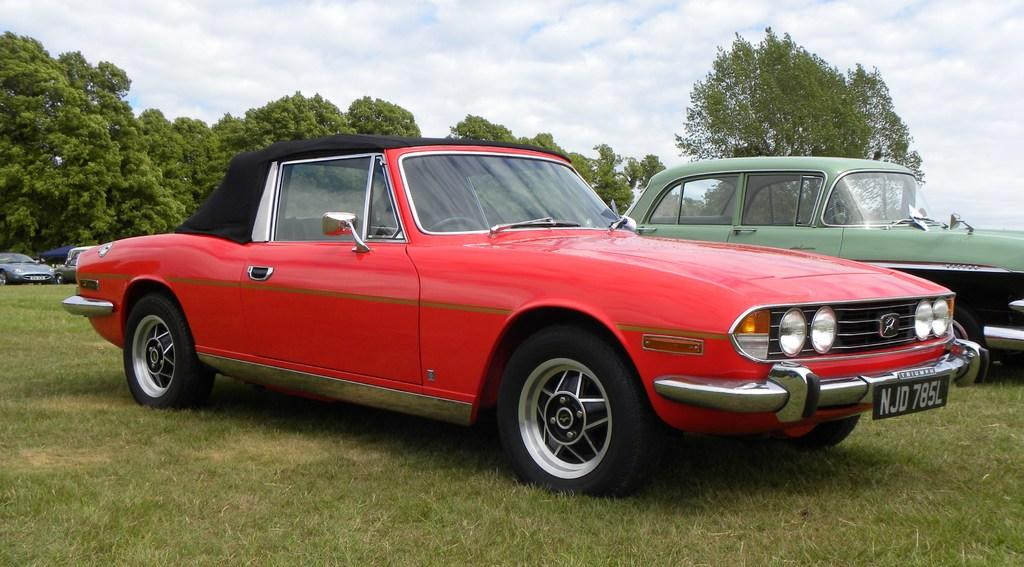What type of vehicles can be seen on the ground level in the image? There are cars on the ground in the image. What type of natural elements can be seen in the image? There are trees visible in the image. What is visible in the background of the image? The sky is visible in the background of the image. What can be observed in the sky? Clouds are present in the sky. How many quarters can be seen on the ground in the image? There are no quarters visible in the image; it features cars on the ground. What type of carriage is present in the image? There is no carriage present in the image; it features cars on the ground. 